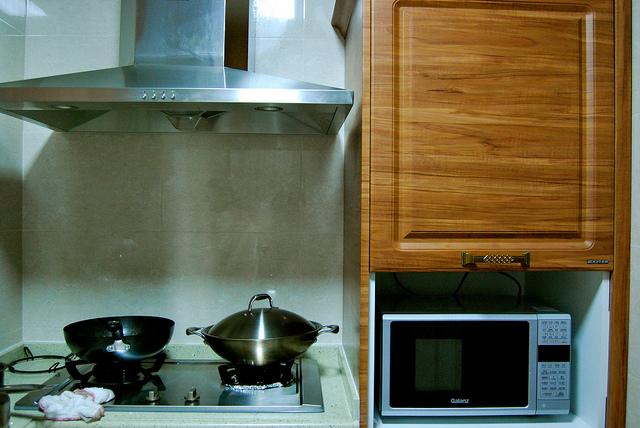What are they cooking?
Write a very short answer. Nothing. How is the stovetop powered?
Be succinct. Gas. Do both these pots have tops on them?
Keep it brief. No. 